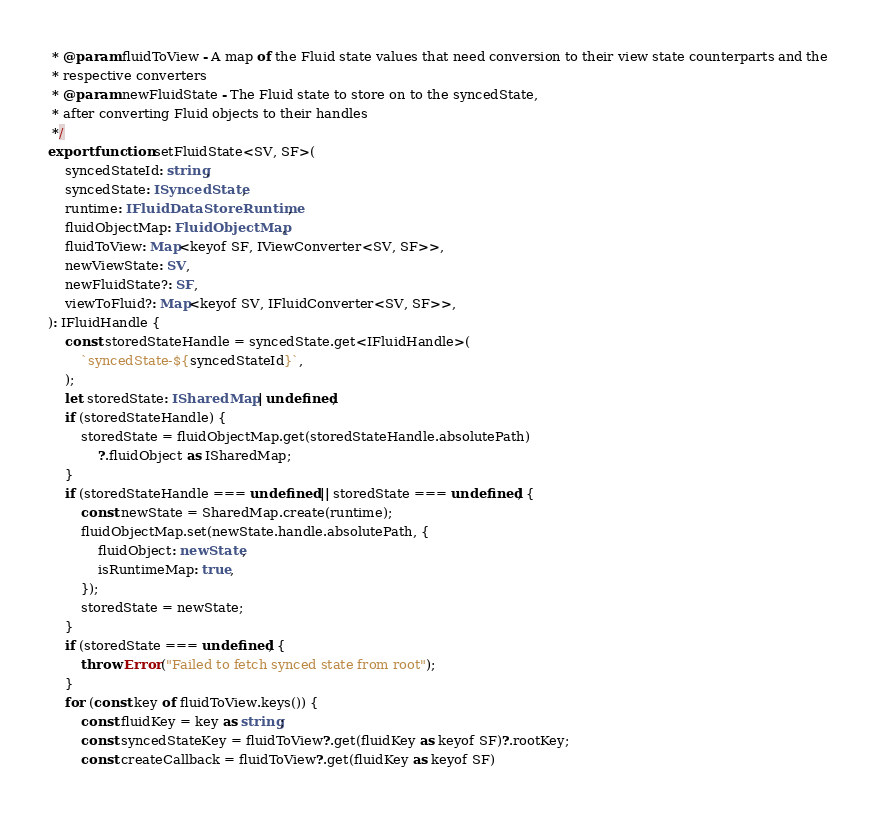<code> <loc_0><loc_0><loc_500><loc_500><_TypeScript_> * @param fluidToView - A map of the Fluid state values that need conversion to their view state counterparts and the
 * respective converters
 * @param newFluidState - The Fluid state to store on to the syncedState,
 * after converting Fluid objects to their handles
 */
export function setFluidState<SV, SF>(
    syncedStateId: string,
    syncedState: ISyncedState,
    runtime: IFluidDataStoreRuntime,
    fluidObjectMap: FluidObjectMap,
    fluidToView: Map<keyof SF, IViewConverter<SV, SF>>,
    newViewState: SV,
    newFluidState?: SF,
    viewToFluid?: Map<keyof SV, IFluidConverter<SV, SF>>,
): IFluidHandle {
    const storedStateHandle = syncedState.get<IFluidHandle>(
        `syncedState-${syncedStateId}`,
    );
    let storedState: ISharedMap | undefined;
    if (storedStateHandle) {
        storedState = fluidObjectMap.get(storedStateHandle.absolutePath)
            ?.fluidObject as ISharedMap;
    }
    if (storedStateHandle === undefined || storedState === undefined) {
        const newState = SharedMap.create(runtime);
        fluidObjectMap.set(newState.handle.absolutePath, {
            fluidObject: newState,
            isRuntimeMap: true,
        });
        storedState = newState;
    }
    if (storedState === undefined) {
        throw Error("Failed to fetch synced state from root");
    }
    for (const key of fluidToView.keys()) {
        const fluidKey = key as string;
        const syncedStateKey = fluidToView?.get(fluidKey as keyof SF)?.rootKey;
        const createCallback = fluidToView?.get(fluidKey as keyof SF)</code> 